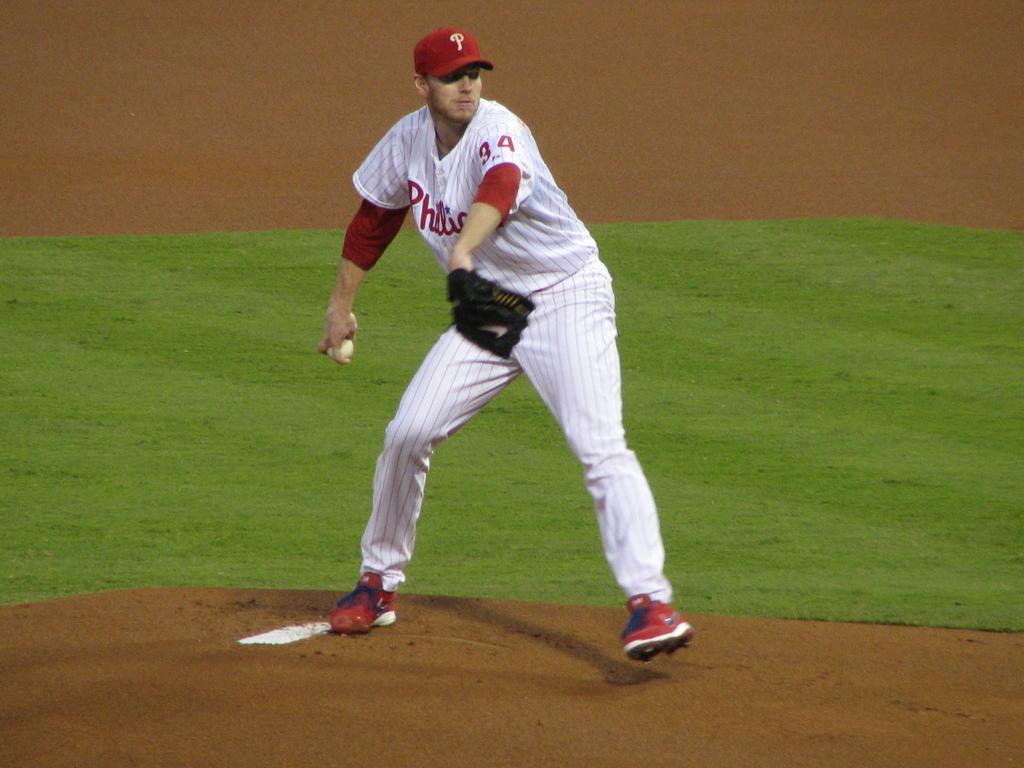What letter is on the hat?
Offer a very short reply. P. What team is the pitcher playing for?
Make the answer very short. Phillies. 